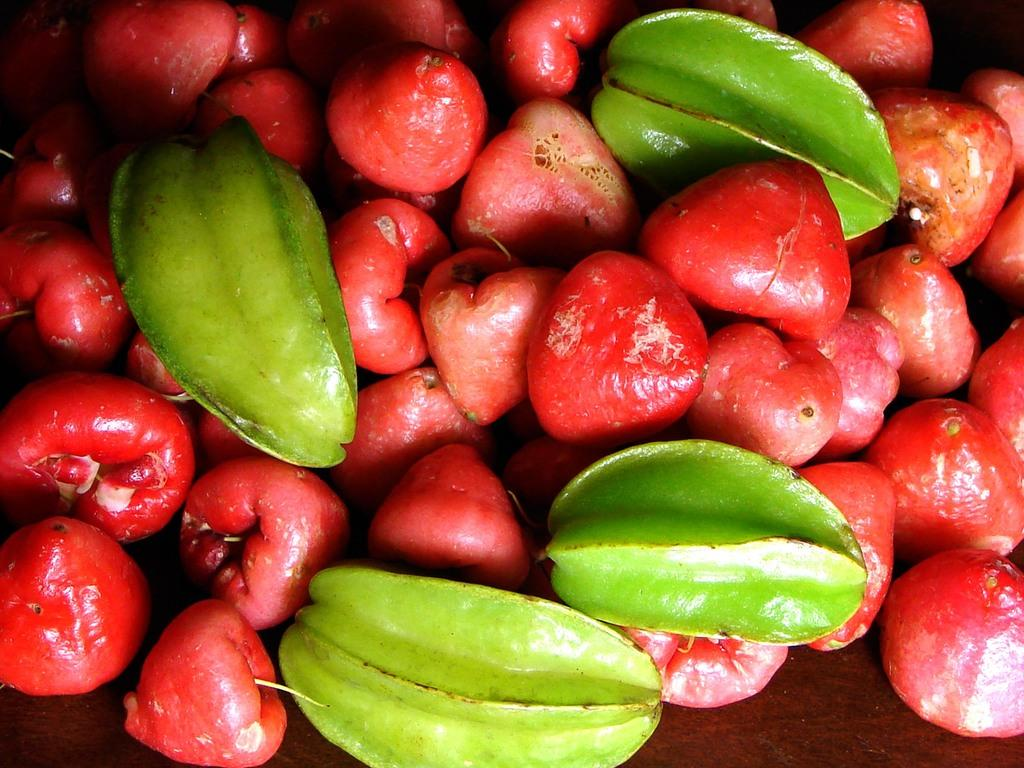What type of food is visible in the image? There are fruits in the image. Can you describe the colors of the fruits? The fruits are in red and green colors. What type of transport is used to carry the fruits in the image? There is no transport visible in the image; it only shows the fruits. Where might someone place these fruits in the image? The image does not show a specific location for the fruits, such as a desk or any other surface. 